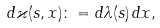<formula> <loc_0><loc_0><loc_500><loc_500>d \varkappa ( s , x ) \colon = d \lambda ( s ) \, d x ,</formula> 